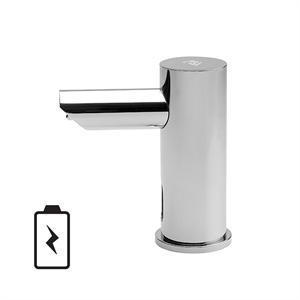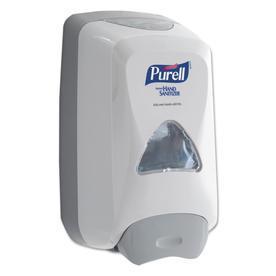The first image is the image on the left, the second image is the image on the right. For the images shown, is this caption "The combined images include a wall-mount dispenser, a horizontal nozzle, and at least one chrome element." true? Answer yes or no. Yes. 